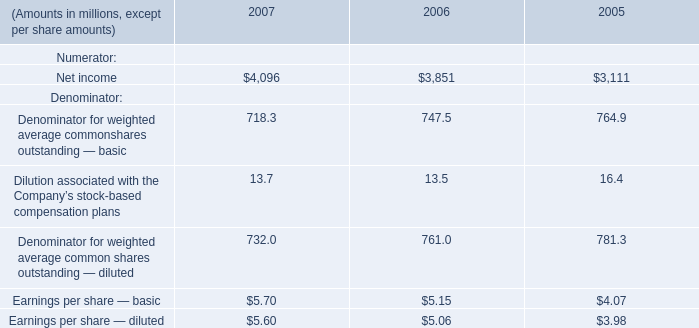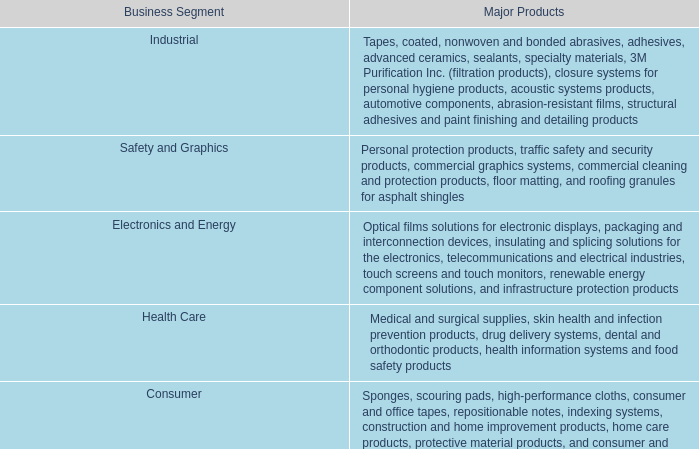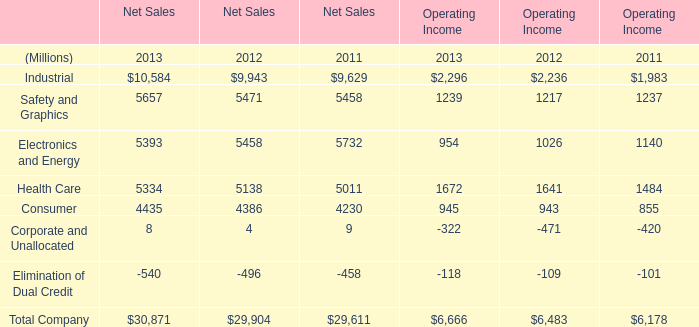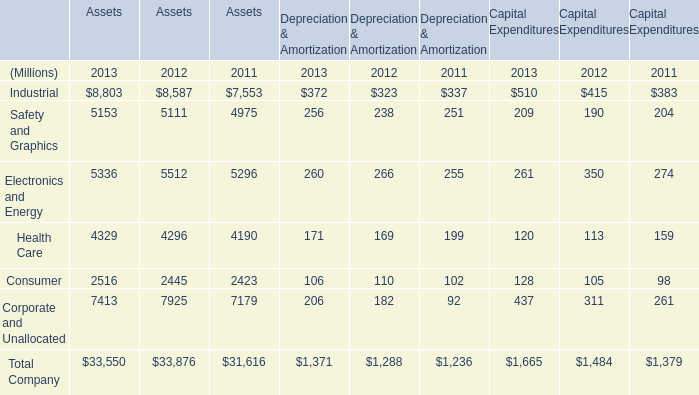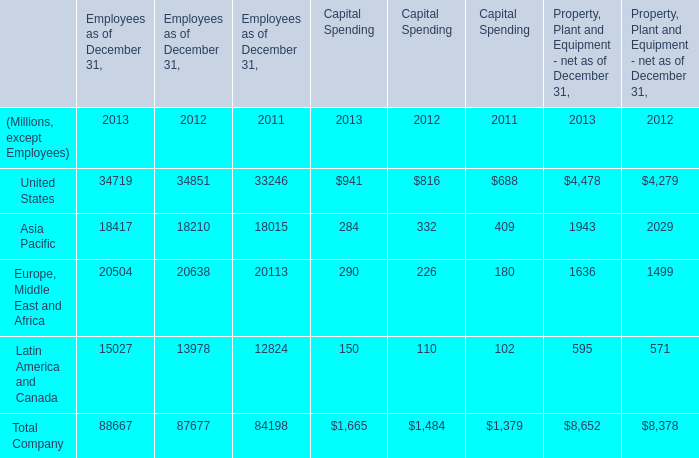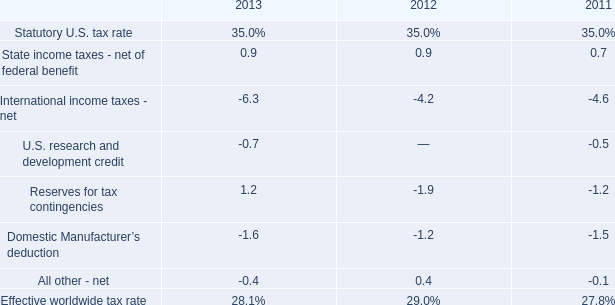In the yearwith the most Consumer, what is the growth rate of Health Care? 
Computations: ((((4329 + 171) + 120) - ((4296 + 169) + 113)) / ((4329 + 171) + 120))
Answer: 0.00909. 